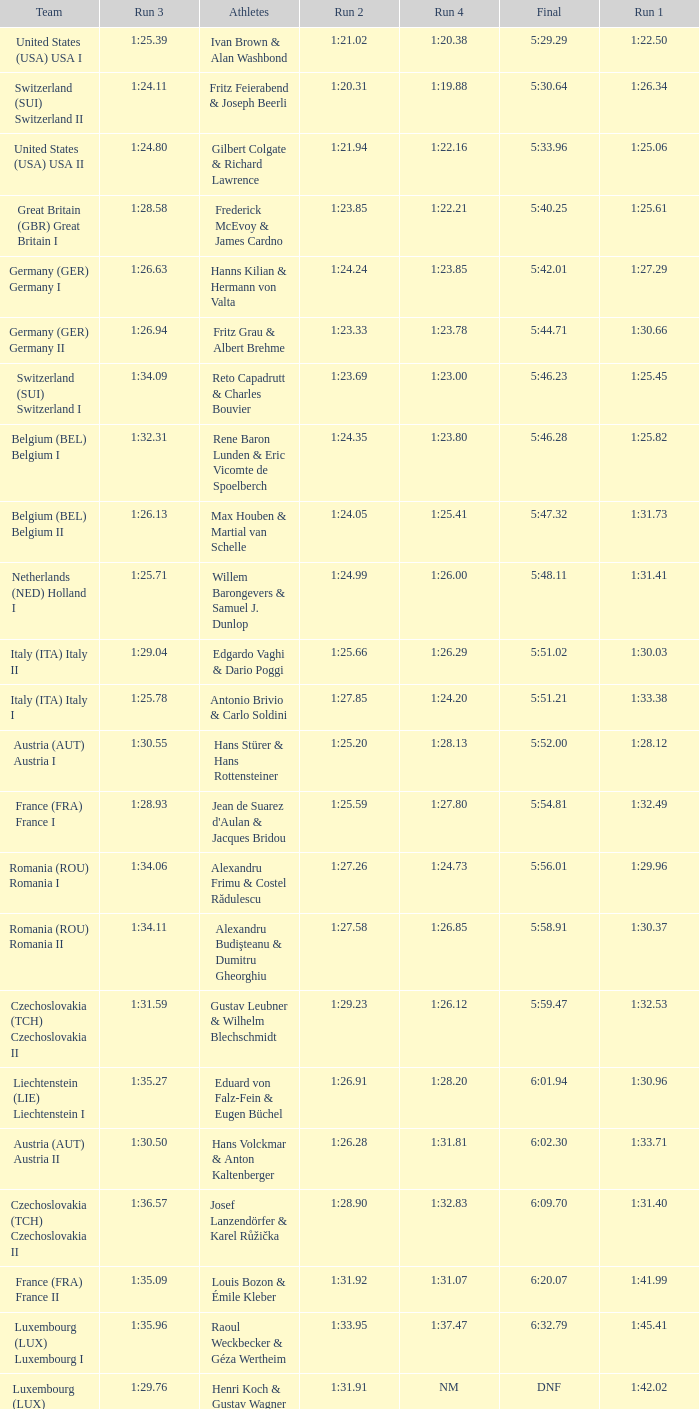Which Final has a Team of liechtenstein (lie) liechtenstein i? 6:01.94. 